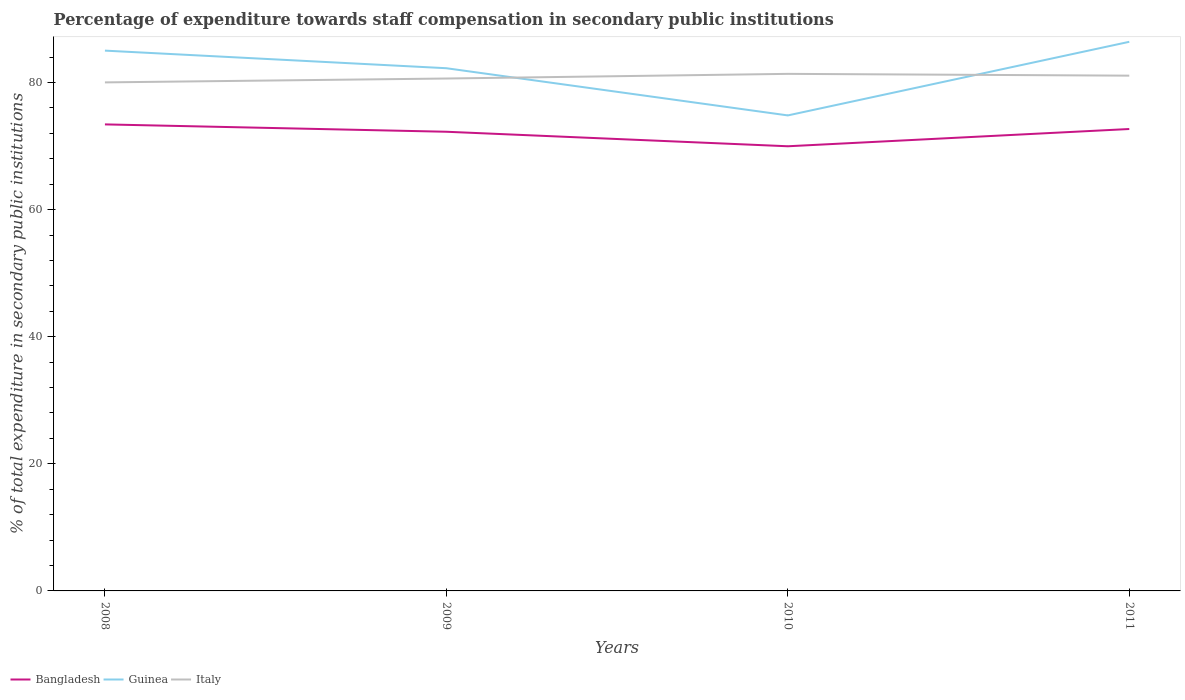How many different coloured lines are there?
Offer a very short reply. 3. Across all years, what is the maximum percentage of expenditure towards staff compensation in Italy?
Give a very brief answer. 80.03. In which year was the percentage of expenditure towards staff compensation in Bangladesh maximum?
Make the answer very short. 2010. What is the total percentage of expenditure towards staff compensation in Bangladesh in the graph?
Your response must be concise. 3.44. What is the difference between the highest and the second highest percentage of expenditure towards staff compensation in Guinea?
Your answer should be compact. 11.59. What is the difference between the highest and the lowest percentage of expenditure towards staff compensation in Italy?
Your response must be concise. 2. Are the values on the major ticks of Y-axis written in scientific E-notation?
Your answer should be compact. No. What is the title of the graph?
Make the answer very short. Percentage of expenditure towards staff compensation in secondary public institutions. What is the label or title of the Y-axis?
Your answer should be compact. % of total expenditure in secondary public institutions. What is the % of total expenditure in secondary public institutions in Bangladesh in 2008?
Provide a short and direct response. 73.42. What is the % of total expenditure in secondary public institutions of Guinea in 2008?
Your response must be concise. 85.03. What is the % of total expenditure in secondary public institutions in Italy in 2008?
Make the answer very short. 80.03. What is the % of total expenditure in secondary public institutions in Bangladesh in 2009?
Offer a very short reply. 72.26. What is the % of total expenditure in secondary public institutions in Guinea in 2009?
Your response must be concise. 82.26. What is the % of total expenditure in secondary public institutions in Italy in 2009?
Offer a terse response. 80.64. What is the % of total expenditure in secondary public institutions of Bangladesh in 2010?
Your answer should be very brief. 69.97. What is the % of total expenditure in secondary public institutions in Guinea in 2010?
Offer a terse response. 74.83. What is the % of total expenditure in secondary public institutions of Italy in 2010?
Your answer should be very brief. 81.37. What is the % of total expenditure in secondary public institutions of Bangladesh in 2011?
Your answer should be very brief. 72.69. What is the % of total expenditure in secondary public institutions in Guinea in 2011?
Your answer should be very brief. 86.42. What is the % of total expenditure in secondary public institutions of Italy in 2011?
Give a very brief answer. 81.09. Across all years, what is the maximum % of total expenditure in secondary public institutions in Bangladesh?
Provide a succinct answer. 73.42. Across all years, what is the maximum % of total expenditure in secondary public institutions in Guinea?
Offer a very short reply. 86.42. Across all years, what is the maximum % of total expenditure in secondary public institutions of Italy?
Offer a terse response. 81.37. Across all years, what is the minimum % of total expenditure in secondary public institutions in Bangladesh?
Your answer should be very brief. 69.97. Across all years, what is the minimum % of total expenditure in secondary public institutions of Guinea?
Your answer should be very brief. 74.83. Across all years, what is the minimum % of total expenditure in secondary public institutions of Italy?
Provide a short and direct response. 80.03. What is the total % of total expenditure in secondary public institutions in Bangladesh in the graph?
Your response must be concise. 288.34. What is the total % of total expenditure in secondary public institutions of Guinea in the graph?
Make the answer very short. 328.53. What is the total % of total expenditure in secondary public institutions in Italy in the graph?
Your answer should be compact. 323.12. What is the difference between the % of total expenditure in secondary public institutions of Bangladesh in 2008 and that in 2009?
Offer a very short reply. 1.16. What is the difference between the % of total expenditure in secondary public institutions in Guinea in 2008 and that in 2009?
Make the answer very short. 2.77. What is the difference between the % of total expenditure in secondary public institutions of Italy in 2008 and that in 2009?
Make the answer very short. -0.61. What is the difference between the % of total expenditure in secondary public institutions in Bangladesh in 2008 and that in 2010?
Give a very brief answer. 3.44. What is the difference between the % of total expenditure in secondary public institutions in Guinea in 2008 and that in 2010?
Provide a succinct answer. 10.2. What is the difference between the % of total expenditure in secondary public institutions in Italy in 2008 and that in 2010?
Your response must be concise. -1.34. What is the difference between the % of total expenditure in secondary public institutions of Bangladesh in 2008 and that in 2011?
Give a very brief answer. 0.73. What is the difference between the % of total expenditure in secondary public institutions of Guinea in 2008 and that in 2011?
Provide a short and direct response. -1.39. What is the difference between the % of total expenditure in secondary public institutions of Italy in 2008 and that in 2011?
Ensure brevity in your answer.  -1.06. What is the difference between the % of total expenditure in secondary public institutions of Bangladesh in 2009 and that in 2010?
Ensure brevity in your answer.  2.29. What is the difference between the % of total expenditure in secondary public institutions of Guinea in 2009 and that in 2010?
Make the answer very short. 7.43. What is the difference between the % of total expenditure in secondary public institutions in Italy in 2009 and that in 2010?
Provide a short and direct response. -0.73. What is the difference between the % of total expenditure in secondary public institutions of Bangladesh in 2009 and that in 2011?
Your answer should be very brief. -0.43. What is the difference between the % of total expenditure in secondary public institutions of Guinea in 2009 and that in 2011?
Provide a short and direct response. -4.16. What is the difference between the % of total expenditure in secondary public institutions of Italy in 2009 and that in 2011?
Provide a short and direct response. -0.45. What is the difference between the % of total expenditure in secondary public institutions of Bangladesh in 2010 and that in 2011?
Provide a succinct answer. -2.72. What is the difference between the % of total expenditure in secondary public institutions of Guinea in 2010 and that in 2011?
Your response must be concise. -11.59. What is the difference between the % of total expenditure in secondary public institutions in Italy in 2010 and that in 2011?
Offer a terse response. 0.28. What is the difference between the % of total expenditure in secondary public institutions in Bangladesh in 2008 and the % of total expenditure in secondary public institutions in Guinea in 2009?
Your response must be concise. -8.84. What is the difference between the % of total expenditure in secondary public institutions of Bangladesh in 2008 and the % of total expenditure in secondary public institutions of Italy in 2009?
Offer a very short reply. -7.22. What is the difference between the % of total expenditure in secondary public institutions of Guinea in 2008 and the % of total expenditure in secondary public institutions of Italy in 2009?
Offer a terse response. 4.39. What is the difference between the % of total expenditure in secondary public institutions in Bangladesh in 2008 and the % of total expenditure in secondary public institutions in Guinea in 2010?
Your answer should be compact. -1.41. What is the difference between the % of total expenditure in secondary public institutions of Bangladesh in 2008 and the % of total expenditure in secondary public institutions of Italy in 2010?
Your answer should be very brief. -7.95. What is the difference between the % of total expenditure in secondary public institutions of Guinea in 2008 and the % of total expenditure in secondary public institutions of Italy in 2010?
Your answer should be very brief. 3.66. What is the difference between the % of total expenditure in secondary public institutions in Bangladesh in 2008 and the % of total expenditure in secondary public institutions in Guinea in 2011?
Offer a very short reply. -13. What is the difference between the % of total expenditure in secondary public institutions of Bangladesh in 2008 and the % of total expenditure in secondary public institutions of Italy in 2011?
Provide a short and direct response. -7.67. What is the difference between the % of total expenditure in secondary public institutions of Guinea in 2008 and the % of total expenditure in secondary public institutions of Italy in 2011?
Offer a terse response. 3.94. What is the difference between the % of total expenditure in secondary public institutions of Bangladesh in 2009 and the % of total expenditure in secondary public institutions of Guinea in 2010?
Your answer should be compact. -2.57. What is the difference between the % of total expenditure in secondary public institutions of Bangladesh in 2009 and the % of total expenditure in secondary public institutions of Italy in 2010?
Keep it short and to the point. -9.11. What is the difference between the % of total expenditure in secondary public institutions in Guinea in 2009 and the % of total expenditure in secondary public institutions in Italy in 2010?
Make the answer very short. 0.89. What is the difference between the % of total expenditure in secondary public institutions in Bangladesh in 2009 and the % of total expenditure in secondary public institutions in Guinea in 2011?
Your answer should be very brief. -14.16. What is the difference between the % of total expenditure in secondary public institutions in Bangladesh in 2009 and the % of total expenditure in secondary public institutions in Italy in 2011?
Offer a terse response. -8.83. What is the difference between the % of total expenditure in secondary public institutions of Guinea in 2009 and the % of total expenditure in secondary public institutions of Italy in 2011?
Give a very brief answer. 1.17. What is the difference between the % of total expenditure in secondary public institutions of Bangladesh in 2010 and the % of total expenditure in secondary public institutions of Guinea in 2011?
Your response must be concise. -16.44. What is the difference between the % of total expenditure in secondary public institutions of Bangladesh in 2010 and the % of total expenditure in secondary public institutions of Italy in 2011?
Give a very brief answer. -11.11. What is the difference between the % of total expenditure in secondary public institutions of Guinea in 2010 and the % of total expenditure in secondary public institutions of Italy in 2011?
Provide a succinct answer. -6.26. What is the average % of total expenditure in secondary public institutions of Bangladesh per year?
Give a very brief answer. 72.09. What is the average % of total expenditure in secondary public institutions in Guinea per year?
Your answer should be very brief. 82.13. What is the average % of total expenditure in secondary public institutions of Italy per year?
Give a very brief answer. 80.78. In the year 2008, what is the difference between the % of total expenditure in secondary public institutions in Bangladesh and % of total expenditure in secondary public institutions in Guinea?
Make the answer very short. -11.61. In the year 2008, what is the difference between the % of total expenditure in secondary public institutions of Bangladesh and % of total expenditure in secondary public institutions of Italy?
Provide a short and direct response. -6.61. In the year 2008, what is the difference between the % of total expenditure in secondary public institutions of Guinea and % of total expenditure in secondary public institutions of Italy?
Offer a terse response. 5. In the year 2009, what is the difference between the % of total expenditure in secondary public institutions in Bangladesh and % of total expenditure in secondary public institutions in Guinea?
Keep it short and to the point. -10. In the year 2009, what is the difference between the % of total expenditure in secondary public institutions of Bangladesh and % of total expenditure in secondary public institutions of Italy?
Your answer should be compact. -8.38. In the year 2009, what is the difference between the % of total expenditure in secondary public institutions of Guinea and % of total expenditure in secondary public institutions of Italy?
Ensure brevity in your answer.  1.62. In the year 2010, what is the difference between the % of total expenditure in secondary public institutions of Bangladesh and % of total expenditure in secondary public institutions of Guinea?
Provide a succinct answer. -4.86. In the year 2010, what is the difference between the % of total expenditure in secondary public institutions of Bangladesh and % of total expenditure in secondary public institutions of Italy?
Offer a terse response. -11.4. In the year 2010, what is the difference between the % of total expenditure in secondary public institutions in Guinea and % of total expenditure in secondary public institutions in Italy?
Your response must be concise. -6.54. In the year 2011, what is the difference between the % of total expenditure in secondary public institutions in Bangladesh and % of total expenditure in secondary public institutions in Guinea?
Your answer should be very brief. -13.72. In the year 2011, what is the difference between the % of total expenditure in secondary public institutions of Bangladesh and % of total expenditure in secondary public institutions of Italy?
Your answer should be very brief. -8.4. In the year 2011, what is the difference between the % of total expenditure in secondary public institutions in Guinea and % of total expenditure in secondary public institutions in Italy?
Offer a terse response. 5.33. What is the ratio of the % of total expenditure in secondary public institutions in Guinea in 2008 to that in 2009?
Provide a succinct answer. 1.03. What is the ratio of the % of total expenditure in secondary public institutions of Italy in 2008 to that in 2009?
Give a very brief answer. 0.99. What is the ratio of the % of total expenditure in secondary public institutions of Bangladesh in 2008 to that in 2010?
Provide a short and direct response. 1.05. What is the ratio of the % of total expenditure in secondary public institutions of Guinea in 2008 to that in 2010?
Provide a succinct answer. 1.14. What is the ratio of the % of total expenditure in secondary public institutions in Italy in 2008 to that in 2010?
Your response must be concise. 0.98. What is the ratio of the % of total expenditure in secondary public institutions in Bangladesh in 2008 to that in 2011?
Offer a very short reply. 1.01. What is the ratio of the % of total expenditure in secondary public institutions of Guinea in 2008 to that in 2011?
Ensure brevity in your answer.  0.98. What is the ratio of the % of total expenditure in secondary public institutions in Italy in 2008 to that in 2011?
Make the answer very short. 0.99. What is the ratio of the % of total expenditure in secondary public institutions in Bangladesh in 2009 to that in 2010?
Offer a very short reply. 1.03. What is the ratio of the % of total expenditure in secondary public institutions in Guinea in 2009 to that in 2010?
Your answer should be very brief. 1.1. What is the ratio of the % of total expenditure in secondary public institutions in Guinea in 2009 to that in 2011?
Offer a very short reply. 0.95. What is the ratio of the % of total expenditure in secondary public institutions in Bangladesh in 2010 to that in 2011?
Your answer should be compact. 0.96. What is the ratio of the % of total expenditure in secondary public institutions of Guinea in 2010 to that in 2011?
Provide a short and direct response. 0.87. What is the ratio of the % of total expenditure in secondary public institutions of Italy in 2010 to that in 2011?
Keep it short and to the point. 1. What is the difference between the highest and the second highest % of total expenditure in secondary public institutions in Bangladesh?
Provide a succinct answer. 0.73. What is the difference between the highest and the second highest % of total expenditure in secondary public institutions in Guinea?
Your answer should be very brief. 1.39. What is the difference between the highest and the second highest % of total expenditure in secondary public institutions of Italy?
Offer a terse response. 0.28. What is the difference between the highest and the lowest % of total expenditure in secondary public institutions in Bangladesh?
Your answer should be very brief. 3.44. What is the difference between the highest and the lowest % of total expenditure in secondary public institutions of Guinea?
Your answer should be very brief. 11.59. What is the difference between the highest and the lowest % of total expenditure in secondary public institutions in Italy?
Provide a short and direct response. 1.34. 